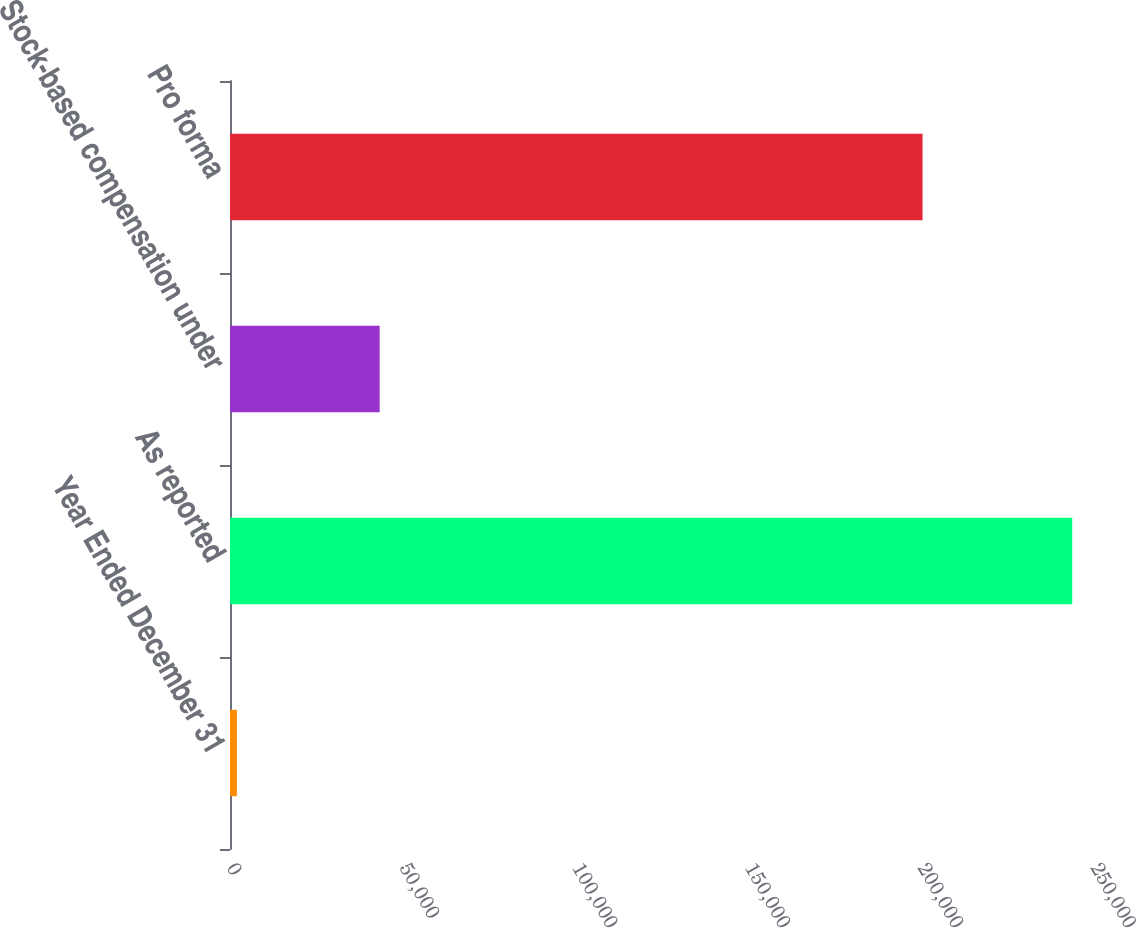Convert chart. <chart><loc_0><loc_0><loc_500><loc_500><bar_chart><fcel>Year Ended December 31<fcel>As reported<fcel>Stock-based compensation under<fcel>Pro forma<nl><fcel>2003<fcel>243697<fcel>43310<fcel>200387<nl></chart> 